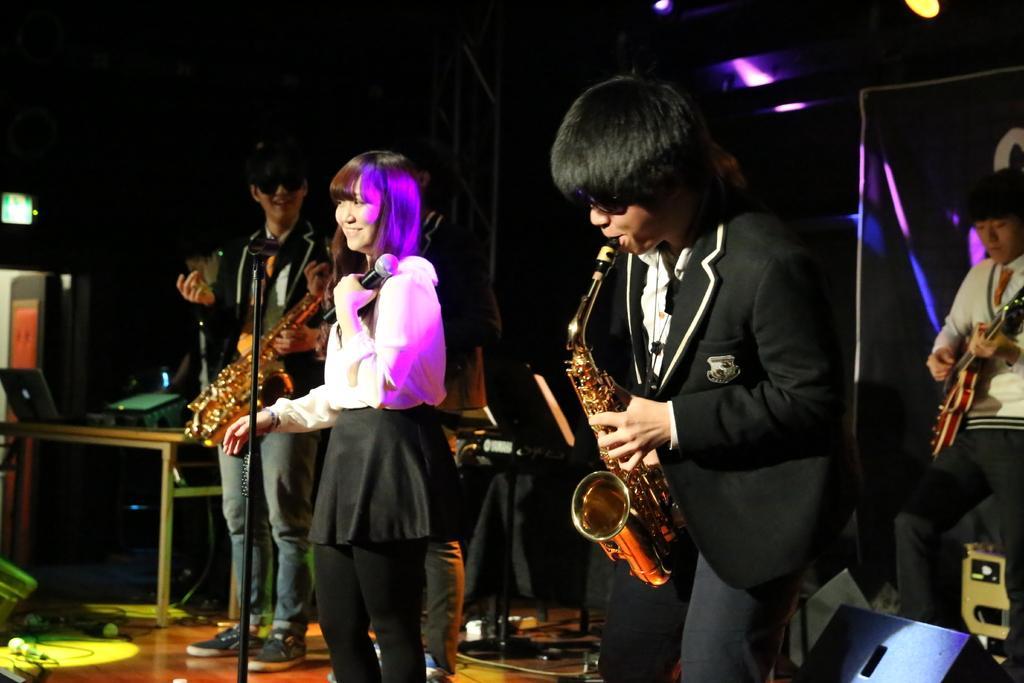Can you describe this image briefly? In this image there are a few people standing and playing a musical instruments, which are in their hands, One of them is holding a mic, in front of her there is a stand of a mic and there are few objects on the stage, there is a table with a laptop and other objects on it. The background is dark and at the top of the image there are few focus lights. 